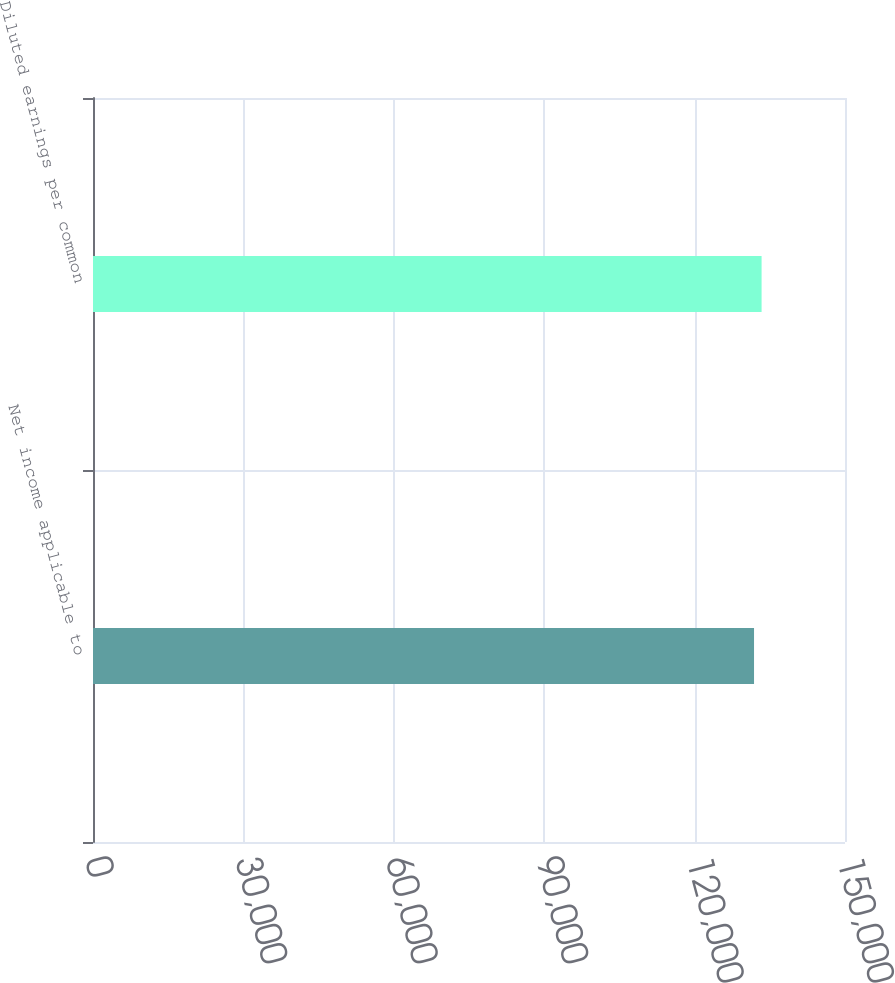Convert chart to OTSL. <chart><loc_0><loc_0><loc_500><loc_500><bar_chart><fcel>Net income applicable to<fcel>Diluted earnings per common<nl><fcel>131854<fcel>133362<nl></chart> 